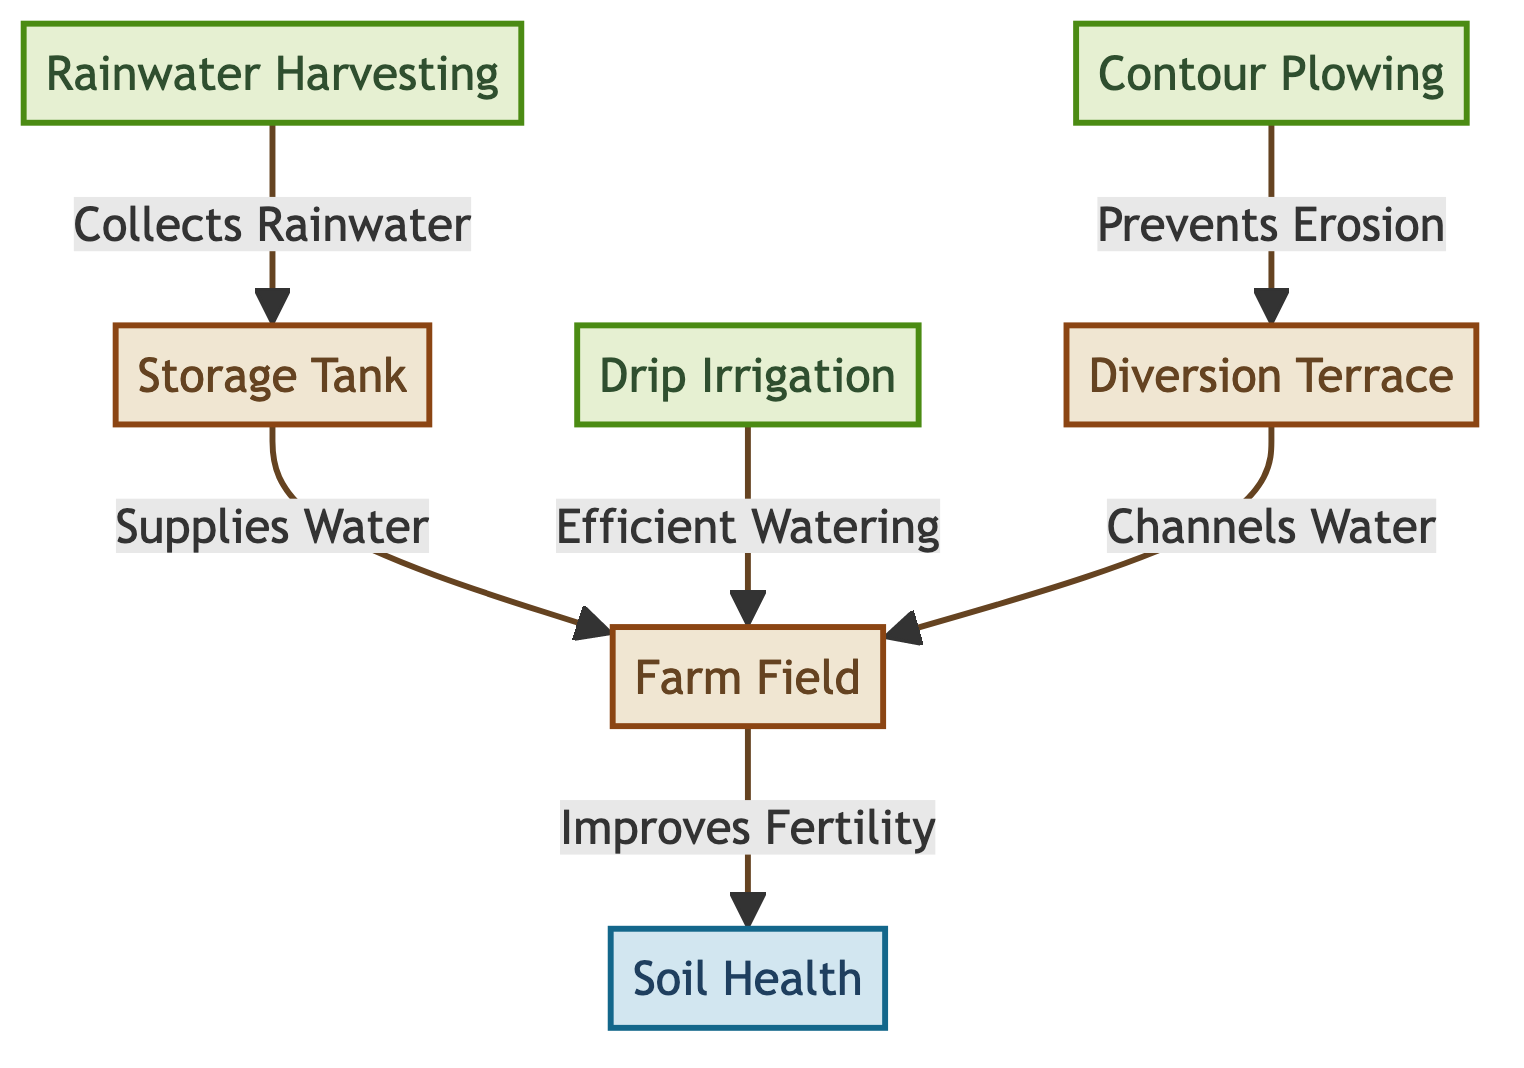What are the three water conservation methods shown in the diagram? The diagram lists three methods: Rainwater Harvesting, Contour Plowing, and Drip Irrigation. These are identified as separate nodes in the diagram.
Answer: Rainwater Harvesting, Contour Plowing, Drip Irrigation Which method collects rainwater? The node labeled "Rainwater Harvesting" is specifically linked to the process of collecting rainwater, as indicated by the arrow showing the relationship.
Answer: Rainwater Harvesting What is the outcome when water is supplied to the farm field? The arrow from "Farm Field" points to "Soil Health," indicating that supplying water to the farm field leads to an improvement in soil health.
Answer: Improves Fertility How does Contour Plowing prevent erosion? The diagram shows Contour Plowing directed towards "Diversion Terrace," indicating that the method prevents erosion by channeling water appropriately.
Answer: Prevents Erosion How many different nodes related to methods are present in the diagram? The diagram features three nodes specifically associated with water conservation methods: Rainwater Harvesting, Contour Plowing, and Drip Irrigation. Counting these gives the total number of method nodes.
Answer: 3 What is the relationship between Diversion Terrace and the Farm Field? The arrow from "Diversion Terrace" to "Farm Field" indicates that it channels water into the farm field, demonstrating how they are connected in this water conservation process.
Answer: Channels Water What is the purpose of the Storage Tank in the diagram? The Storage Tank serves the purpose of supplying collected rainwater to the Farm Field, as noted in the relationship depicted between these two nodes in the diagram.
Answer: Supplies Water Which water conservation technique provides efficient watering? The diagram clearly shows that Drip Irrigation is responsible for efficient watering, as denoted by the direct connection from Drip Irrigation to the Farm Field.
Answer: Drip Irrigation 